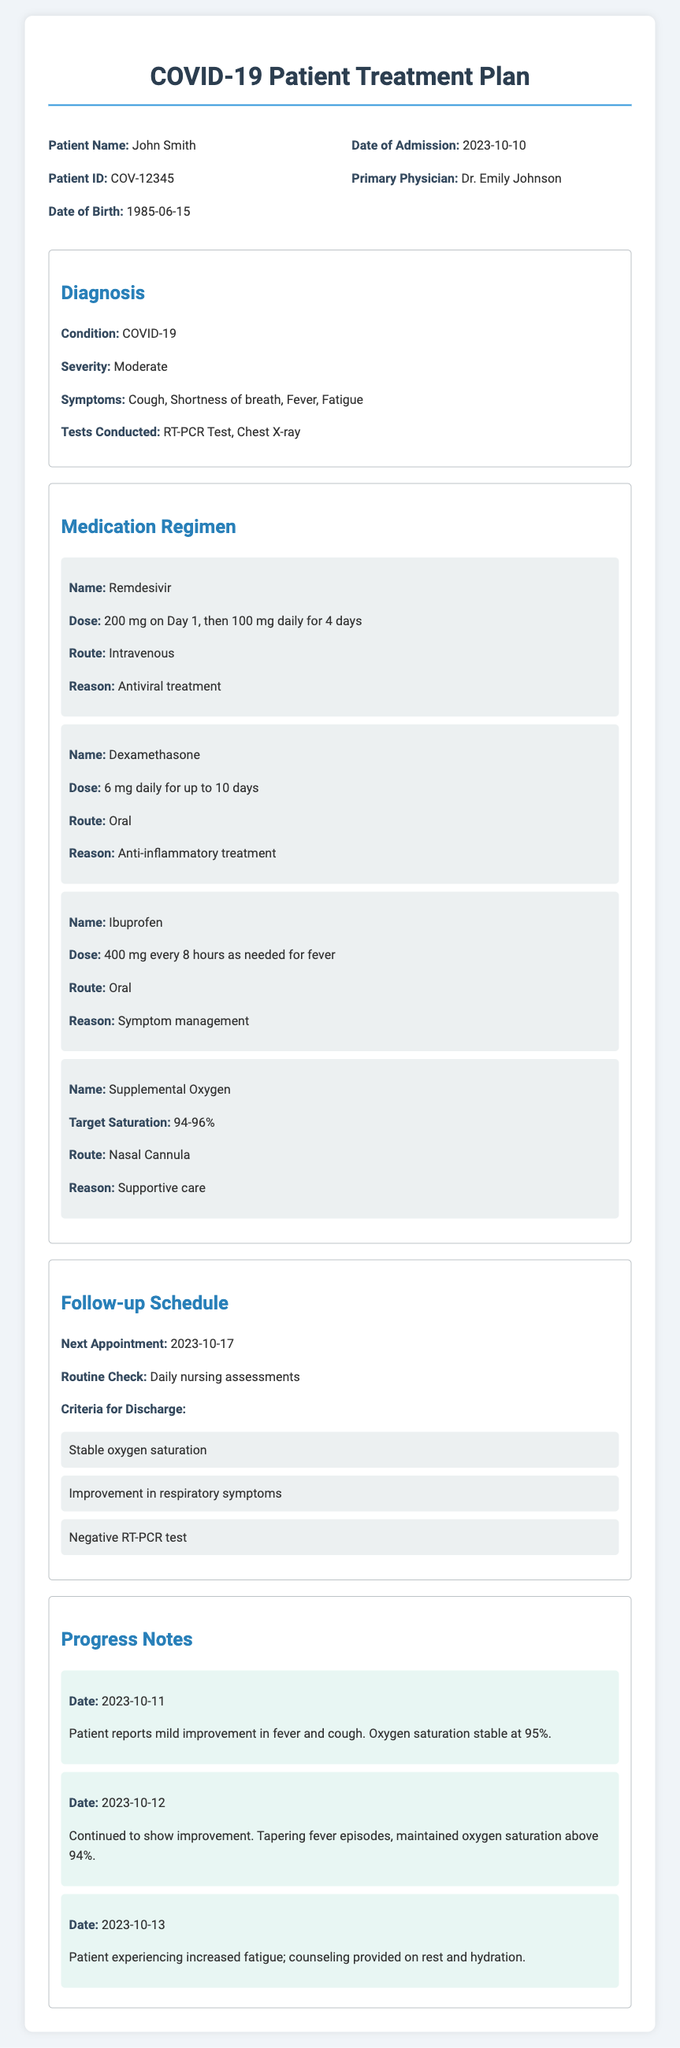What is the patient's name? The patient's name is listed in the document, which reads "Patient Name: John Smith".
Answer: John Smith What is the patient's ID? The patient's ID is provided in the document as "Patient ID: COV-12345".
Answer: COV-12345 What is the medication regimen for Remdesivir? The medication regimen for Remdesivir states the dose as "200 mg on Day 1, then 100 mg daily for 4 days".
Answer: 200 mg on Day 1, then 100 mg daily for 4 days What is the target saturation for Supplemental Oxygen? The document specifies "Target Saturation: 94-96%" for Supplemental Oxygen.
Answer: 94-96% When is the next appointment scheduled? The document mentions the next appointment as "2023-10-17".
Answer: 2023-10-17 What are the criteria for discharge? The criteria for discharge include three points that are listed in the document.
Answer: Stable oxygen saturation, Improvement in respiratory symptoms, Negative RT-PCR test What has been noted about the patient's oxygen saturation on 2023-10-11? The progress note for 2023-10-11 indicates that "Oxygen saturation stable at 95%".
Answer: 95% What is the primary physician's name? The primary physician is stated as "Dr. Emily Johnson" in the document.
Answer: Dr. Emily Johnson What is the severity of the COVID-19 condition? The document refers to the severity described as "Moderate".
Answer: Moderate 